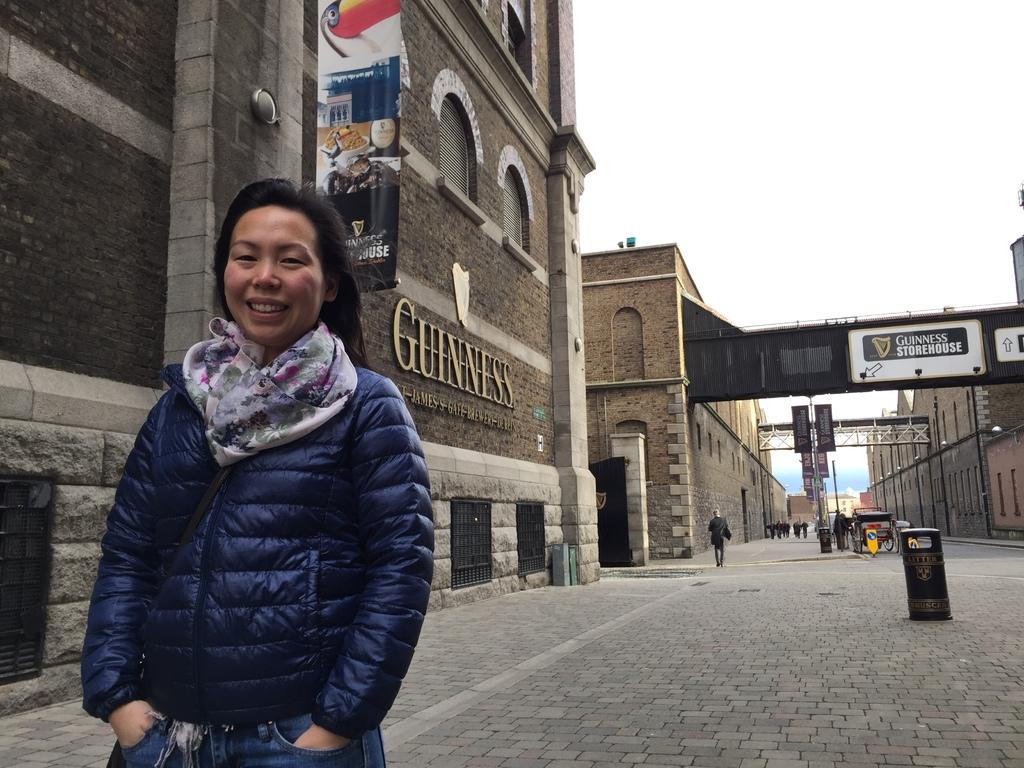Who is the main subject in the image? There is a woman in the image. What is the woman's position in relation to the ground? The woman is standing on the ground. What can be seen in the distance behind the woman? There are buildings and the sky visible in the background of the image. Are there any other people in the image besides the woman? Yes, there are persons in the background of the image. What type of linen is draped over the town in the image? There is no town or linen present in the image. What kind of picture is the woman holding in the image? There is no picture visible in the image. 